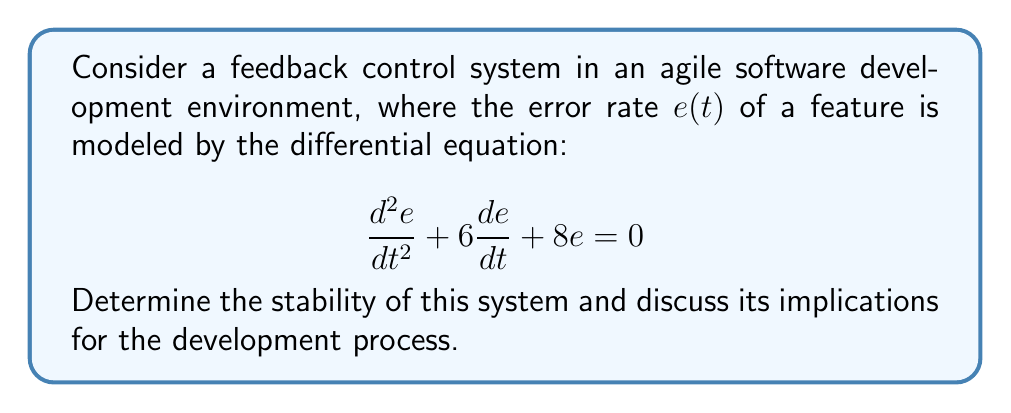What is the answer to this math problem? To analyze the stability of this feedback control system, we need to follow these steps:

1) First, we recognize this as a second-order homogeneous linear differential equation.

2) The characteristic equation for this system is:
   $$r^2 + 6r + 8 = 0$$

3) We can solve this quadratic equation using the quadratic formula:
   $$r = \frac{-b \pm \sqrt{b^2 - 4ac}}{2a}$$
   where $a=1$, $b=6$, and $c=8$

4) Substituting these values:
   $$r = \frac{-6 \pm \sqrt{36 - 32}}{2} = \frac{-6 \pm \sqrt{4}}{2} = \frac{-6 \pm 2}{2}$$

5) This gives us two roots:
   $$r_1 = \frac{-6 + 2}{2} = -2$$
   $$r_2 = \frac{-6 - 2}{2} = -4$$

6) The general solution to this differential equation is:
   $$e(t) = C_1e^{-2t} + C_2e^{-4t}$$
   where $C_1$ and $C_2$ are constants determined by initial conditions.

7) For a system to be stable, the real parts of all roots must be negative. In this case, both roots (-2 and -4) are negative real numbers.

8) This means the system is asymptotically stable. As $t$ increases, both $e^{-2t}$ and $e^{-4t}$ approach zero, so $e(t)$ will approach zero regardless of the initial conditions.

In the context of agile software development, this stability implies that the error rate will naturally decrease over time without additional intervention. This aligns well with agile philosophies, as it suggests that the iterative process of development and testing will lead to a reduction in errors. The team can focus on continuous improvement and delivering value, trusting that the feedback control system will help manage and reduce errors over time.
Answer: The system is asymptotically stable. Both roots of the characteristic equation are negative real numbers (-2 and -4), indicating that the error rate $e(t)$ will approach zero as time increases, regardless of initial conditions. 